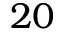Convert formula to latex. <formula><loc_0><loc_0><loc_500><loc_500>2 0</formula> 